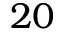Convert formula to latex. <formula><loc_0><loc_0><loc_500><loc_500>2 0</formula> 